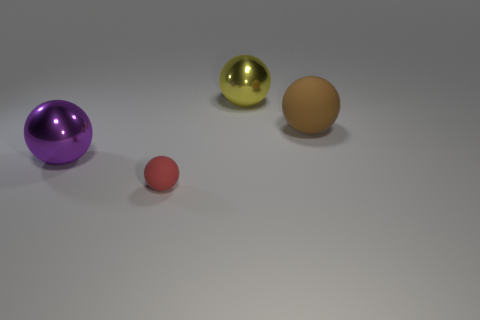Subtract all big spheres. How many spheres are left? 1 Add 3 purple rubber cylinders. How many objects exist? 7 Subtract 4 spheres. How many spheres are left? 0 Subtract all purple spheres. How many spheres are left? 3 Subtract 1 red balls. How many objects are left? 3 Subtract all blue balls. Subtract all purple cylinders. How many balls are left? 4 Subtract all yellow cylinders. How many gray balls are left? 0 Subtract all brown matte balls. Subtract all purple metal balls. How many objects are left? 2 Add 1 red matte spheres. How many red matte spheres are left? 2 Add 1 tiny yellow objects. How many tiny yellow objects exist? 1 